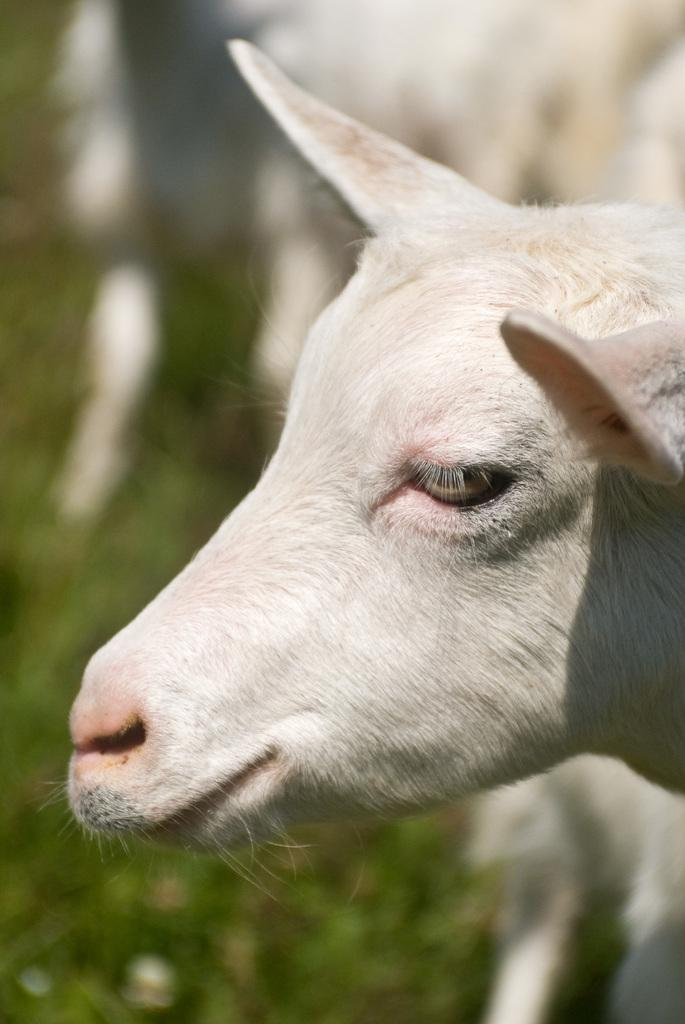What animal's face is depicted in the image? There is a sheep face in the image. What type of light source is used to improve the health of the sheep in the image? There is no information about a light source or the sheep's health in the image, as it only features a sheep face. 